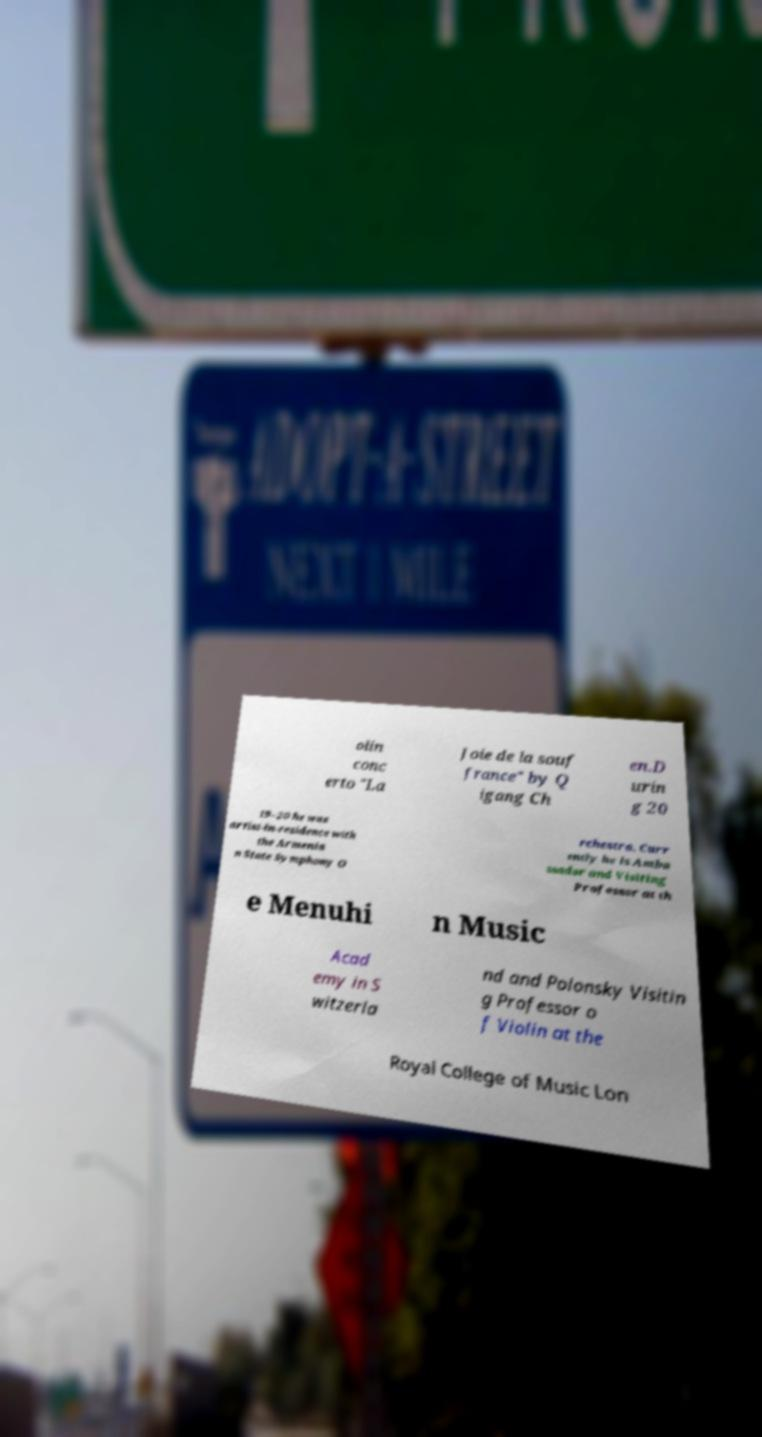What messages or text are displayed in this image? I need them in a readable, typed format. olin conc erto "La Joie de la souf france" by Q igang Ch en.D urin g 20 19–20 he was artist-in-residence with the Armenia n State Symphony O rchestra. Curr ently he is Amba ssador and Visiting Professor at th e Menuhi n Music Acad emy in S witzerla nd and Polonsky Visitin g Professor o f Violin at the Royal College of Music Lon 